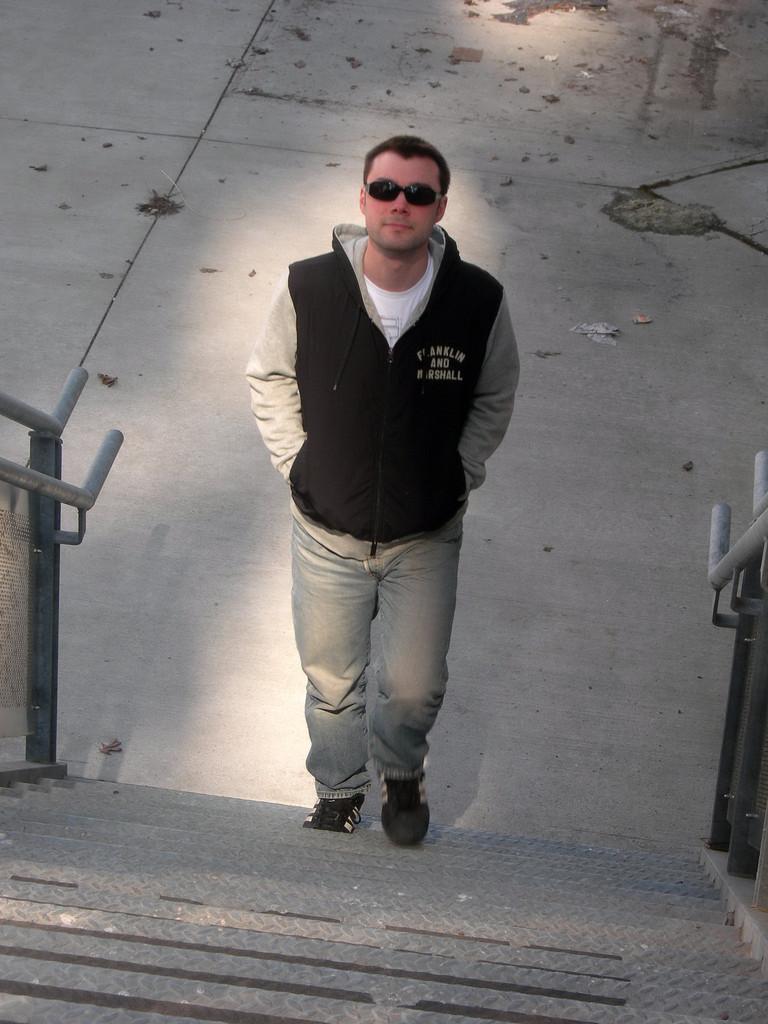Could you give a brief overview of what you see in this image? In this image there is a man walking on stairs, on either side of the stairs there is a railing, in the background there is pavement. 